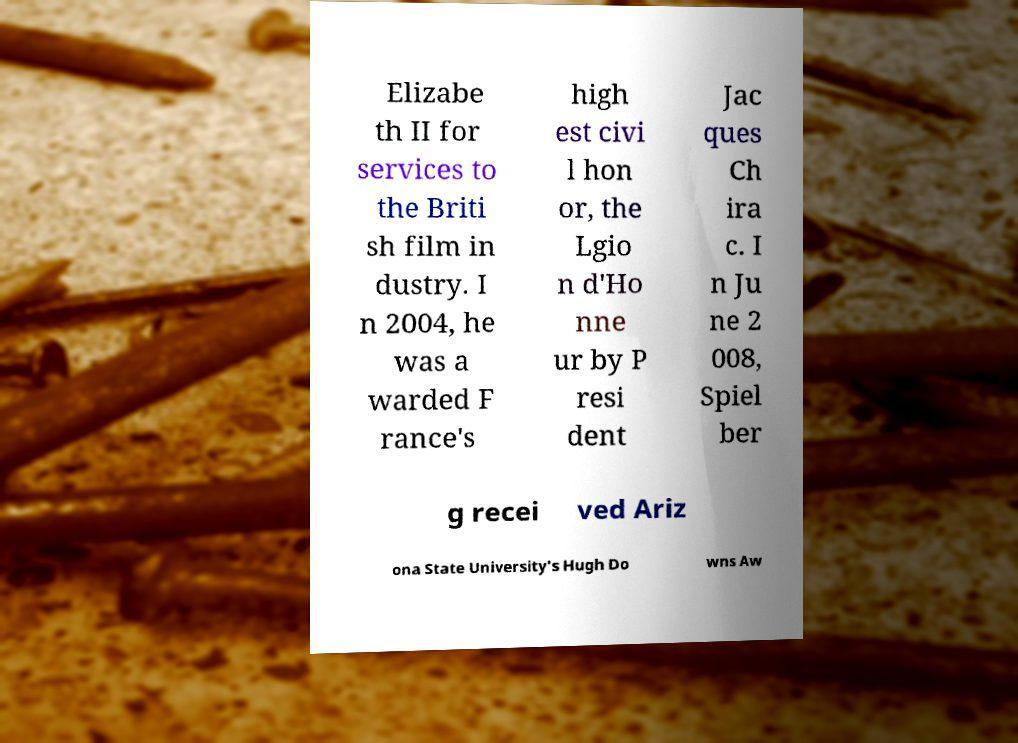Could you extract and type out the text from this image? Elizabe th II for services to the Briti sh film in dustry. I n 2004, he was a warded F rance's high est civi l hon or, the Lgio n d'Ho nne ur by P resi dent Jac ques Ch ira c. I n Ju ne 2 008, Spiel ber g recei ved Ariz ona State University's Hugh Do wns Aw 